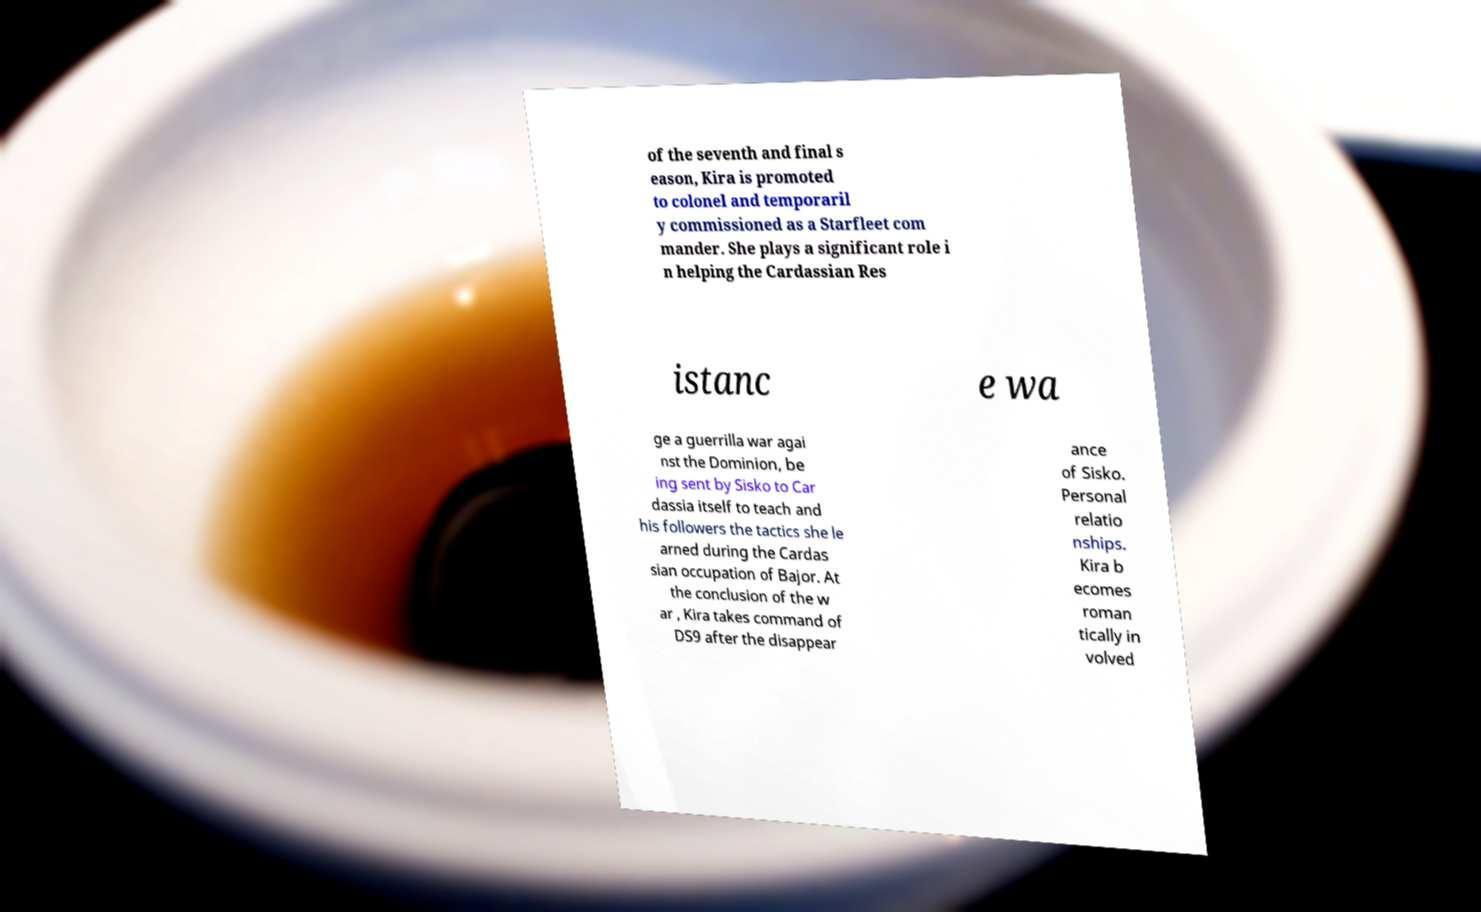For documentation purposes, I need the text within this image transcribed. Could you provide that? of the seventh and final s eason, Kira is promoted to colonel and temporaril y commissioned as a Starfleet com mander. She plays a significant role i n helping the Cardassian Res istanc e wa ge a guerrilla war agai nst the Dominion, be ing sent by Sisko to Car dassia itself to teach and his followers the tactics she le arned during the Cardas sian occupation of Bajor. At the conclusion of the w ar , Kira takes command of DS9 after the disappear ance of Sisko. Personal relatio nships. Kira b ecomes roman tically in volved 